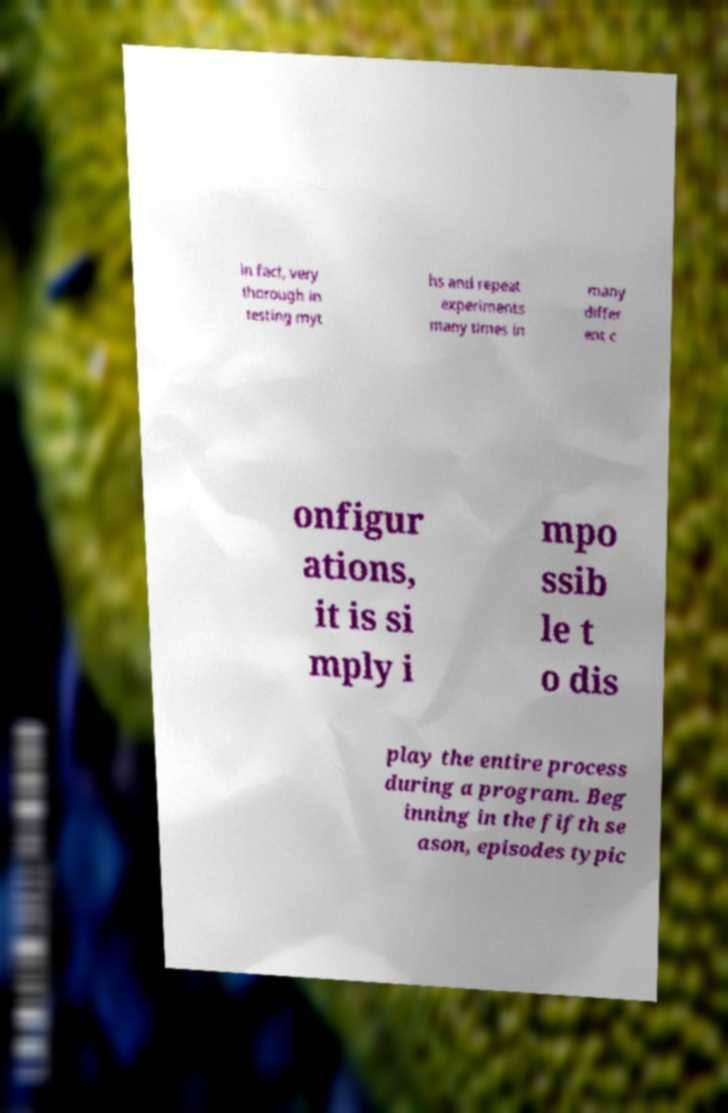I need the written content from this picture converted into text. Can you do that? in fact, very thorough in testing myt hs and repeat experiments many times in many differ ent c onfigur ations, it is si mply i mpo ssib le t o dis play the entire process during a program. Beg inning in the fifth se ason, episodes typic 